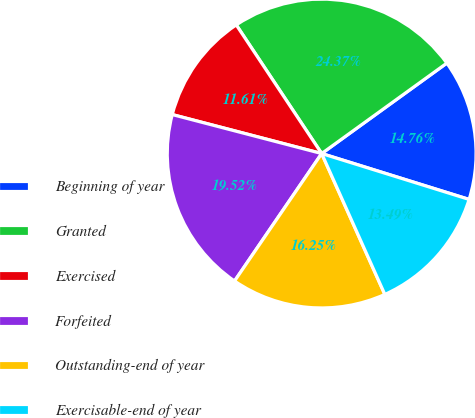Convert chart. <chart><loc_0><loc_0><loc_500><loc_500><pie_chart><fcel>Beginning of year<fcel>Granted<fcel>Exercised<fcel>Forfeited<fcel>Outstanding-end of year<fcel>Exercisable-end of year<nl><fcel>14.76%<fcel>24.37%<fcel>11.61%<fcel>19.52%<fcel>16.25%<fcel>13.49%<nl></chart> 